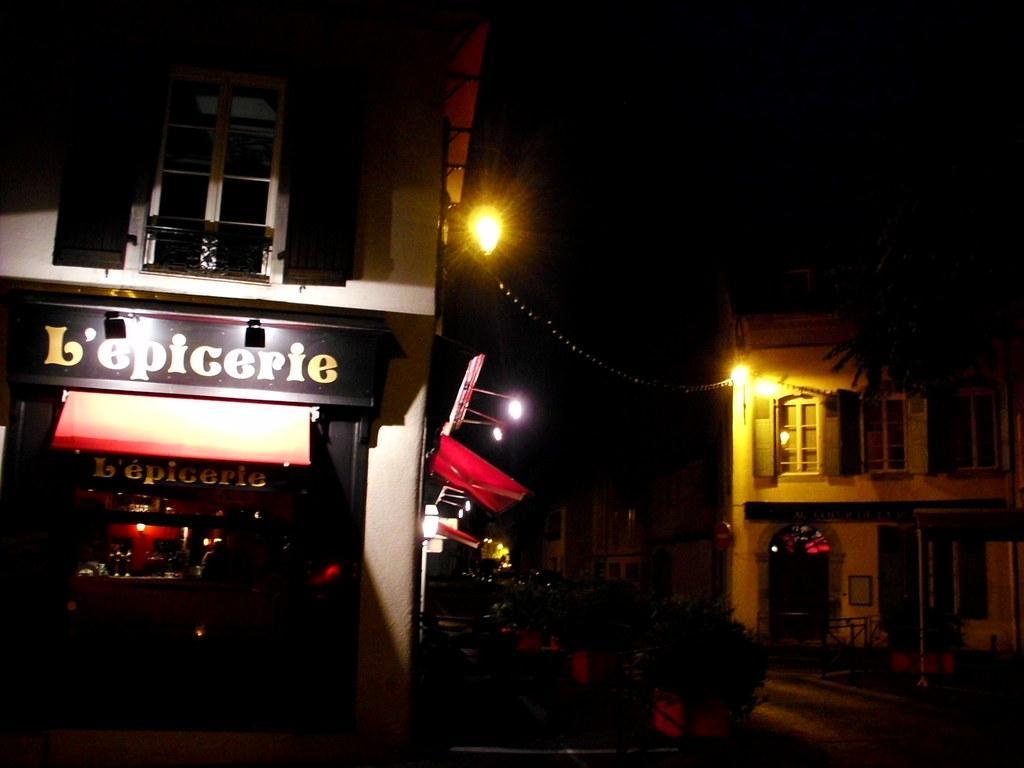Please provide a concise description of this image. This picture is clicked outside the city. On the left side, we see a building and a board in black color with some text written on it. Beside that, we see the boards and the banners in white and red color. In the middle of the picture, we see the plant pots. On the right side, we see a pole and a building. In the background, it is black in color and this picture is clicked in the dark. 